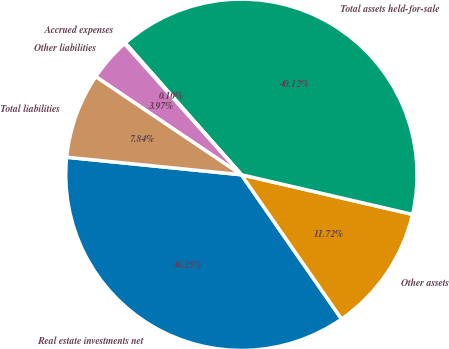Convert chart to OTSL. <chart><loc_0><loc_0><loc_500><loc_500><pie_chart><fcel>Real estate investments net<fcel>Other assets<fcel>Total assets held-for-sale<fcel>Accrued expenses<fcel>Other liabilities<fcel>Total liabilities<nl><fcel>36.25%<fcel>11.72%<fcel>40.12%<fcel>0.1%<fcel>3.97%<fcel>7.84%<nl></chart> 